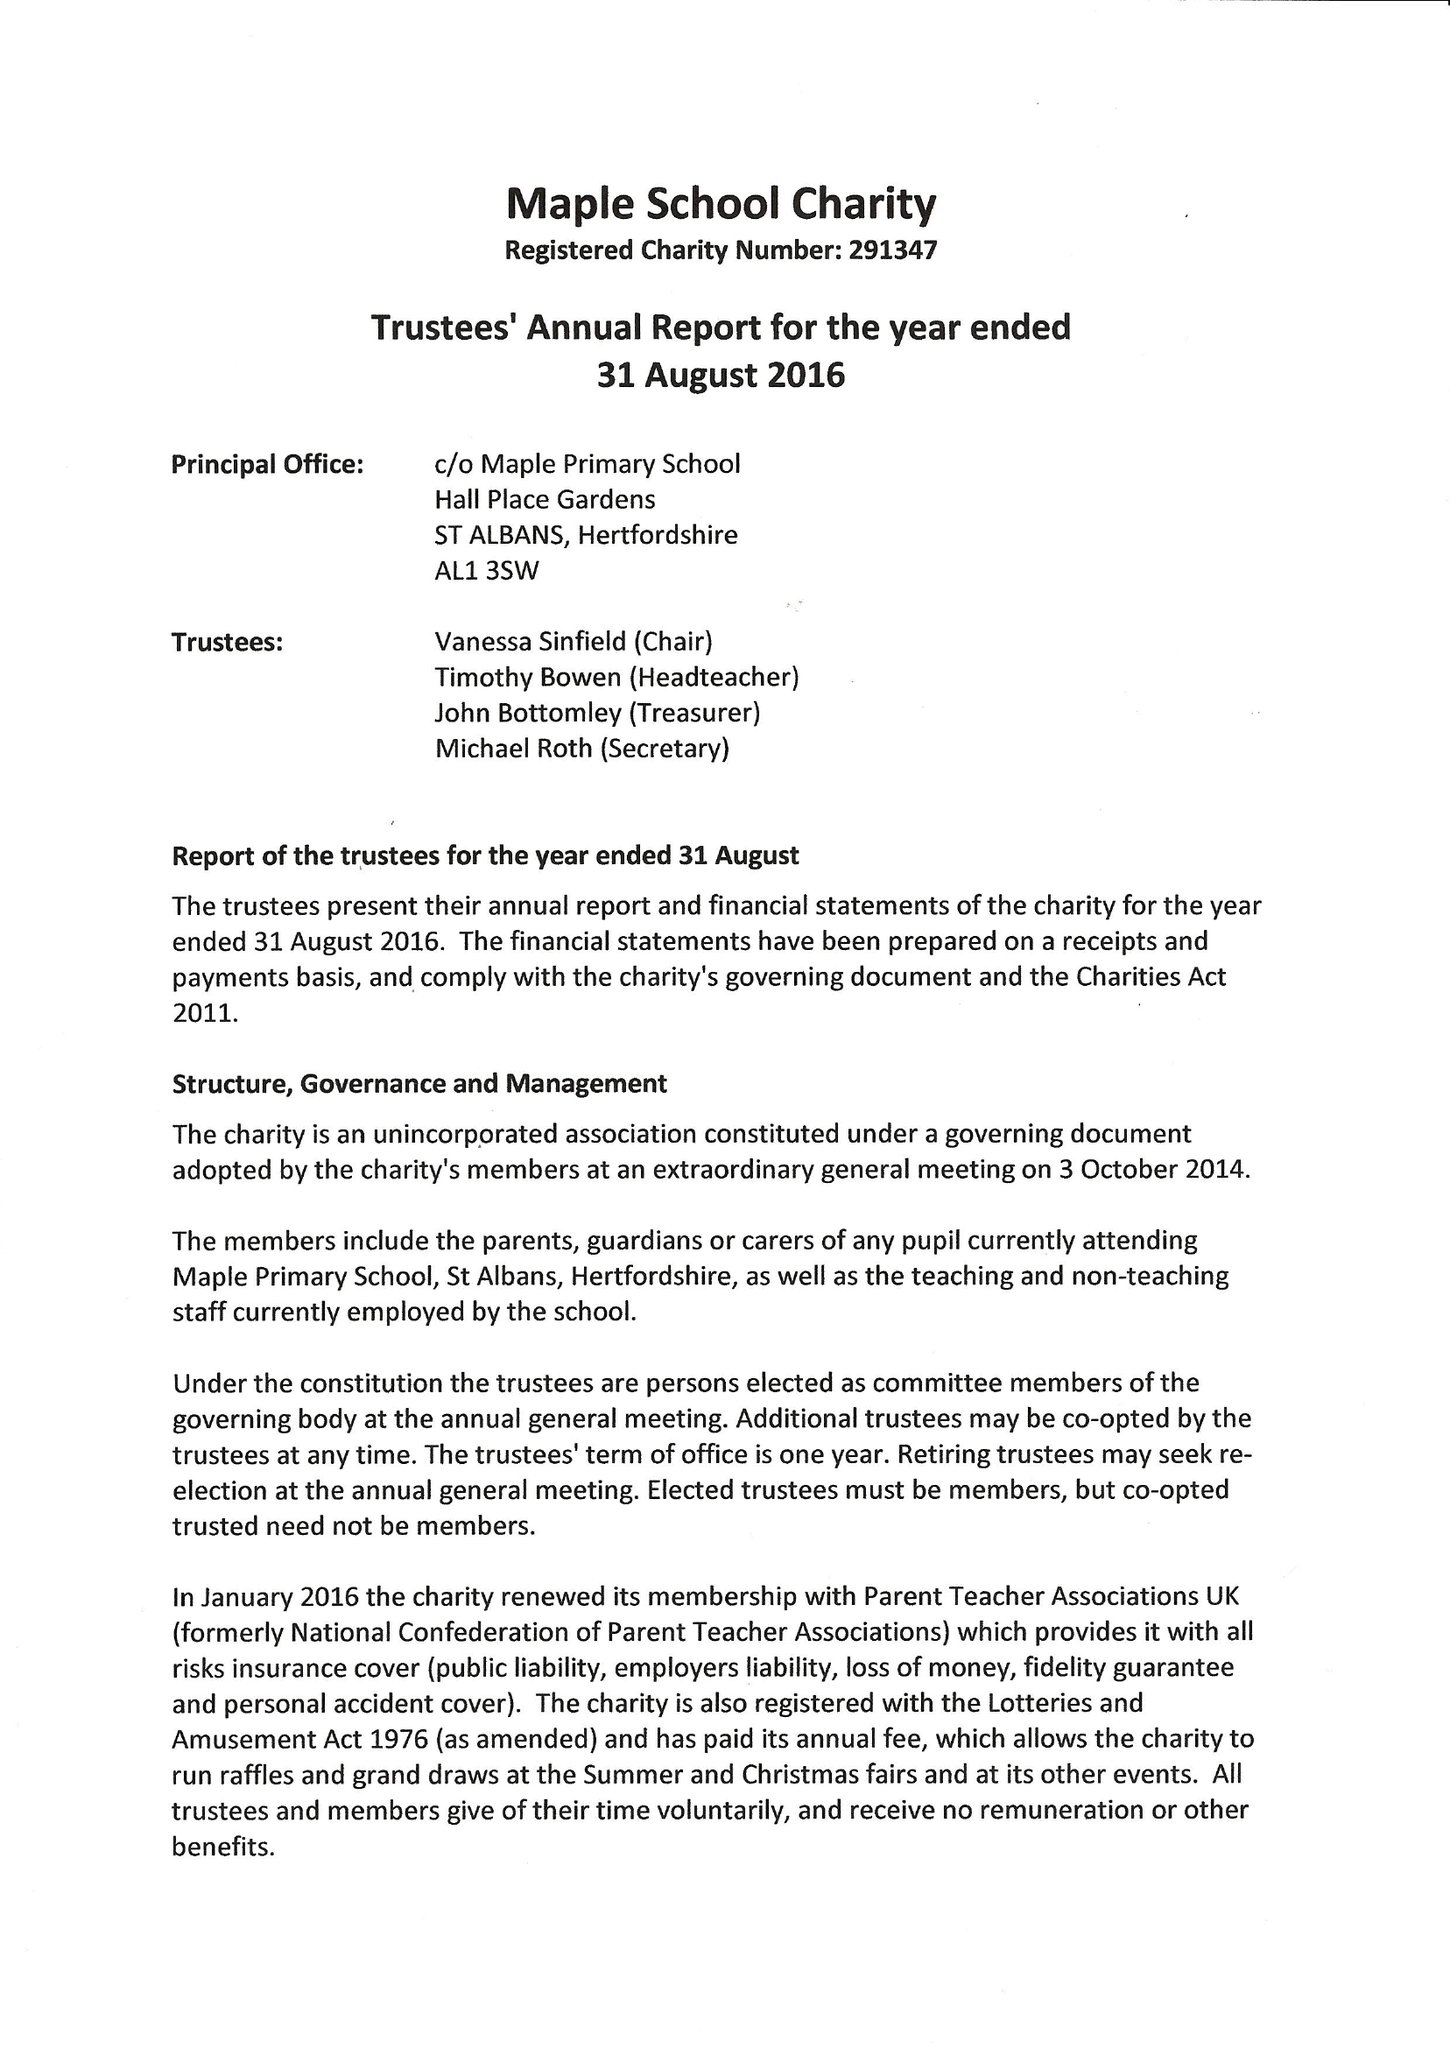What is the value for the address__street_line?
Answer the question using a single word or phrase. HALL PLACE GARDENS 